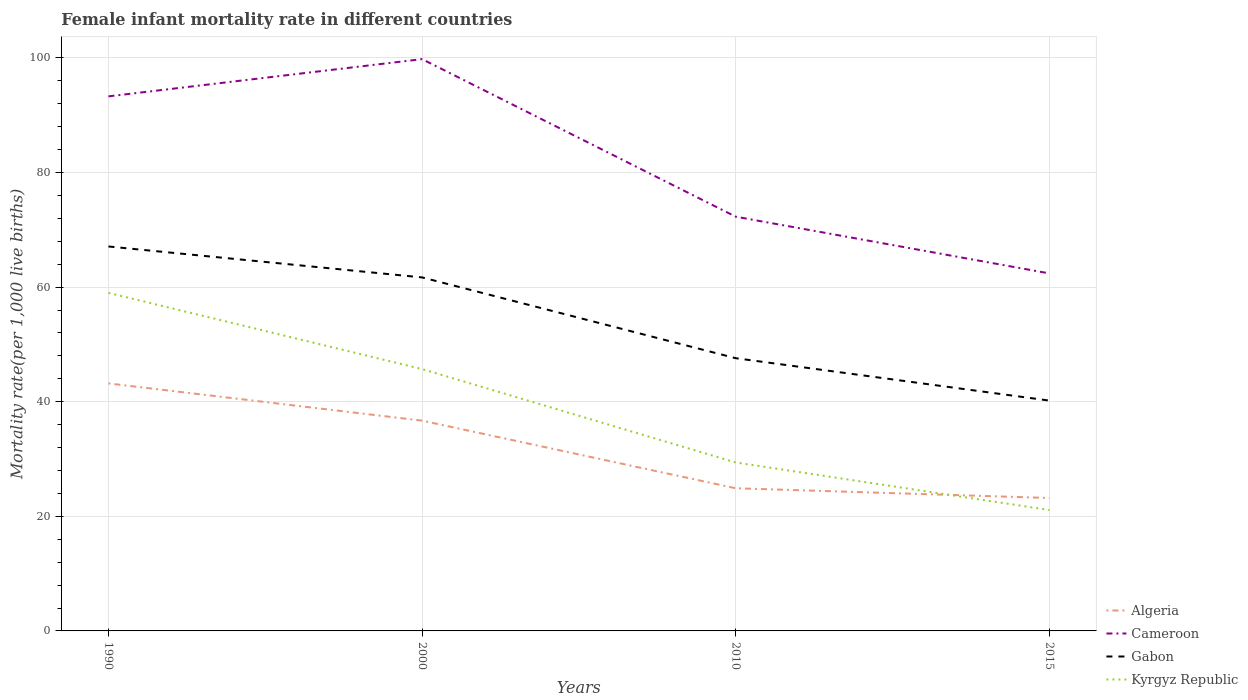How many different coloured lines are there?
Offer a terse response. 4. Across all years, what is the maximum female infant mortality rate in Gabon?
Your answer should be compact. 40.2. In which year was the female infant mortality rate in Cameroon maximum?
Your answer should be very brief. 2015. What is the total female infant mortality rate in Kyrgyz Republic in the graph?
Offer a terse response. 8.3. What is the difference between the highest and the second highest female infant mortality rate in Algeria?
Offer a terse response. 20. What is the difference between the highest and the lowest female infant mortality rate in Kyrgyz Republic?
Ensure brevity in your answer.  2. Is the female infant mortality rate in Kyrgyz Republic strictly greater than the female infant mortality rate in Cameroon over the years?
Give a very brief answer. Yes. How many years are there in the graph?
Give a very brief answer. 4. Are the values on the major ticks of Y-axis written in scientific E-notation?
Offer a terse response. No. Does the graph contain any zero values?
Make the answer very short. No. Does the graph contain grids?
Your answer should be very brief. Yes. How many legend labels are there?
Your answer should be compact. 4. How are the legend labels stacked?
Offer a terse response. Vertical. What is the title of the graph?
Give a very brief answer. Female infant mortality rate in different countries. Does "Azerbaijan" appear as one of the legend labels in the graph?
Your answer should be very brief. No. What is the label or title of the X-axis?
Provide a succinct answer. Years. What is the label or title of the Y-axis?
Your answer should be very brief. Mortality rate(per 1,0 live births). What is the Mortality rate(per 1,000 live births) of Algeria in 1990?
Your answer should be very brief. 43.2. What is the Mortality rate(per 1,000 live births) in Cameroon in 1990?
Offer a terse response. 93.3. What is the Mortality rate(per 1,000 live births) of Gabon in 1990?
Your answer should be very brief. 67.1. What is the Mortality rate(per 1,000 live births) of Kyrgyz Republic in 1990?
Give a very brief answer. 59. What is the Mortality rate(per 1,000 live births) of Algeria in 2000?
Offer a terse response. 36.7. What is the Mortality rate(per 1,000 live births) in Cameroon in 2000?
Keep it short and to the point. 99.8. What is the Mortality rate(per 1,000 live births) of Gabon in 2000?
Keep it short and to the point. 61.7. What is the Mortality rate(per 1,000 live births) of Kyrgyz Republic in 2000?
Provide a short and direct response. 45.7. What is the Mortality rate(per 1,000 live births) of Algeria in 2010?
Provide a succinct answer. 24.9. What is the Mortality rate(per 1,000 live births) in Cameroon in 2010?
Keep it short and to the point. 72.3. What is the Mortality rate(per 1,000 live births) in Gabon in 2010?
Offer a very short reply. 47.6. What is the Mortality rate(per 1,000 live births) of Kyrgyz Republic in 2010?
Your response must be concise. 29.4. What is the Mortality rate(per 1,000 live births) in Algeria in 2015?
Give a very brief answer. 23.2. What is the Mortality rate(per 1,000 live births) of Cameroon in 2015?
Give a very brief answer. 62.4. What is the Mortality rate(per 1,000 live births) in Gabon in 2015?
Keep it short and to the point. 40.2. What is the Mortality rate(per 1,000 live births) of Kyrgyz Republic in 2015?
Offer a terse response. 21.1. Across all years, what is the maximum Mortality rate(per 1,000 live births) of Algeria?
Keep it short and to the point. 43.2. Across all years, what is the maximum Mortality rate(per 1,000 live births) in Cameroon?
Your answer should be compact. 99.8. Across all years, what is the maximum Mortality rate(per 1,000 live births) in Gabon?
Your answer should be compact. 67.1. Across all years, what is the minimum Mortality rate(per 1,000 live births) of Algeria?
Your answer should be very brief. 23.2. Across all years, what is the minimum Mortality rate(per 1,000 live births) of Cameroon?
Your answer should be very brief. 62.4. Across all years, what is the minimum Mortality rate(per 1,000 live births) of Gabon?
Offer a very short reply. 40.2. Across all years, what is the minimum Mortality rate(per 1,000 live births) of Kyrgyz Republic?
Make the answer very short. 21.1. What is the total Mortality rate(per 1,000 live births) in Algeria in the graph?
Your answer should be compact. 128. What is the total Mortality rate(per 1,000 live births) of Cameroon in the graph?
Keep it short and to the point. 327.8. What is the total Mortality rate(per 1,000 live births) in Gabon in the graph?
Your response must be concise. 216.6. What is the total Mortality rate(per 1,000 live births) in Kyrgyz Republic in the graph?
Your answer should be very brief. 155.2. What is the difference between the Mortality rate(per 1,000 live births) in Cameroon in 1990 and that in 2000?
Give a very brief answer. -6.5. What is the difference between the Mortality rate(per 1,000 live births) of Kyrgyz Republic in 1990 and that in 2000?
Your response must be concise. 13.3. What is the difference between the Mortality rate(per 1,000 live births) of Cameroon in 1990 and that in 2010?
Your answer should be very brief. 21. What is the difference between the Mortality rate(per 1,000 live births) of Kyrgyz Republic in 1990 and that in 2010?
Provide a short and direct response. 29.6. What is the difference between the Mortality rate(per 1,000 live births) in Algeria in 1990 and that in 2015?
Make the answer very short. 20. What is the difference between the Mortality rate(per 1,000 live births) of Cameroon in 1990 and that in 2015?
Your answer should be compact. 30.9. What is the difference between the Mortality rate(per 1,000 live births) of Gabon in 1990 and that in 2015?
Offer a terse response. 26.9. What is the difference between the Mortality rate(per 1,000 live births) of Kyrgyz Republic in 1990 and that in 2015?
Provide a succinct answer. 37.9. What is the difference between the Mortality rate(per 1,000 live births) of Algeria in 2000 and that in 2010?
Your answer should be very brief. 11.8. What is the difference between the Mortality rate(per 1,000 live births) of Cameroon in 2000 and that in 2010?
Give a very brief answer. 27.5. What is the difference between the Mortality rate(per 1,000 live births) of Kyrgyz Republic in 2000 and that in 2010?
Give a very brief answer. 16.3. What is the difference between the Mortality rate(per 1,000 live births) of Cameroon in 2000 and that in 2015?
Offer a very short reply. 37.4. What is the difference between the Mortality rate(per 1,000 live births) in Kyrgyz Republic in 2000 and that in 2015?
Keep it short and to the point. 24.6. What is the difference between the Mortality rate(per 1,000 live births) in Algeria in 2010 and that in 2015?
Make the answer very short. 1.7. What is the difference between the Mortality rate(per 1,000 live births) in Gabon in 2010 and that in 2015?
Your response must be concise. 7.4. What is the difference between the Mortality rate(per 1,000 live births) of Kyrgyz Republic in 2010 and that in 2015?
Ensure brevity in your answer.  8.3. What is the difference between the Mortality rate(per 1,000 live births) in Algeria in 1990 and the Mortality rate(per 1,000 live births) in Cameroon in 2000?
Make the answer very short. -56.6. What is the difference between the Mortality rate(per 1,000 live births) of Algeria in 1990 and the Mortality rate(per 1,000 live births) of Gabon in 2000?
Provide a succinct answer. -18.5. What is the difference between the Mortality rate(per 1,000 live births) in Algeria in 1990 and the Mortality rate(per 1,000 live births) in Kyrgyz Republic in 2000?
Give a very brief answer. -2.5. What is the difference between the Mortality rate(per 1,000 live births) in Cameroon in 1990 and the Mortality rate(per 1,000 live births) in Gabon in 2000?
Offer a very short reply. 31.6. What is the difference between the Mortality rate(per 1,000 live births) in Cameroon in 1990 and the Mortality rate(per 1,000 live births) in Kyrgyz Republic in 2000?
Give a very brief answer. 47.6. What is the difference between the Mortality rate(per 1,000 live births) of Gabon in 1990 and the Mortality rate(per 1,000 live births) of Kyrgyz Republic in 2000?
Your answer should be compact. 21.4. What is the difference between the Mortality rate(per 1,000 live births) in Algeria in 1990 and the Mortality rate(per 1,000 live births) in Cameroon in 2010?
Provide a succinct answer. -29.1. What is the difference between the Mortality rate(per 1,000 live births) in Cameroon in 1990 and the Mortality rate(per 1,000 live births) in Gabon in 2010?
Provide a short and direct response. 45.7. What is the difference between the Mortality rate(per 1,000 live births) of Cameroon in 1990 and the Mortality rate(per 1,000 live births) of Kyrgyz Republic in 2010?
Your answer should be very brief. 63.9. What is the difference between the Mortality rate(per 1,000 live births) in Gabon in 1990 and the Mortality rate(per 1,000 live births) in Kyrgyz Republic in 2010?
Offer a terse response. 37.7. What is the difference between the Mortality rate(per 1,000 live births) of Algeria in 1990 and the Mortality rate(per 1,000 live births) of Cameroon in 2015?
Give a very brief answer. -19.2. What is the difference between the Mortality rate(per 1,000 live births) in Algeria in 1990 and the Mortality rate(per 1,000 live births) in Gabon in 2015?
Ensure brevity in your answer.  3. What is the difference between the Mortality rate(per 1,000 live births) of Algeria in 1990 and the Mortality rate(per 1,000 live births) of Kyrgyz Republic in 2015?
Keep it short and to the point. 22.1. What is the difference between the Mortality rate(per 1,000 live births) of Cameroon in 1990 and the Mortality rate(per 1,000 live births) of Gabon in 2015?
Your response must be concise. 53.1. What is the difference between the Mortality rate(per 1,000 live births) of Cameroon in 1990 and the Mortality rate(per 1,000 live births) of Kyrgyz Republic in 2015?
Make the answer very short. 72.2. What is the difference between the Mortality rate(per 1,000 live births) of Algeria in 2000 and the Mortality rate(per 1,000 live births) of Cameroon in 2010?
Give a very brief answer. -35.6. What is the difference between the Mortality rate(per 1,000 live births) in Algeria in 2000 and the Mortality rate(per 1,000 live births) in Kyrgyz Republic in 2010?
Offer a very short reply. 7.3. What is the difference between the Mortality rate(per 1,000 live births) of Cameroon in 2000 and the Mortality rate(per 1,000 live births) of Gabon in 2010?
Offer a terse response. 52.2. What is the difference between the Mortality rate(per 1,000 live births) of Cameroon in 2000 and the Mortality rate(per 1,000 live births) of Kyrgyz Republic in 2010?
Your response must be concise. 70.4. What is the difference between the Mortality rate(per 1,000 live births) in Gabon in 2000 and the Mortality rate(per 1,000 live births) in Kyrgyz Republic in 2010?
Make the answer very short. 32.3. What is the difference between the Mortality rate(per 1,000 live births) of Algeria in 2000 and the Mortality rate(per 1,000 live births) of Cameroon in 2015?
Make the answer very short. -25.7. What is the difference between the Mortality rate(per 1,000 live births) of Cameroon in 2000 and the Mortality rate(per 1,000 live births) of Gabon in 2015?
Make the answer very short. 59.6. What is the difference between the Mortality rate(per 1,000 live births) in Cameroon in 2000 and the Mortality rate(per 1,000 live births) in Kyrgyz Republic in 2015?
Offer a terse response. 78.7. What is the difference between the Mortality rate(per 1,000 live births) in Gabon in 2000 and the Mortality rate(per 1,000 live births) in Kyrgyz Republic in 2015?
Keep it short and to the point. 40.6. What is the difference between the Mortality rate(per 1,000 live births) of Algeria in 2010 and the Mortality rate(per 1,000 live births) of Cameroon in 2015?
Offer a very short reply. -37.5. What is the difference between the Mortality rate(per 1,000 live births) in Algeria in 2010 and the Mortality rate(per 1,000 live births) in Gabon in 2015?
Your answer should be very brief. -15.3. What is the difference between the Mortality rate(per 1,000 live births) in Algeria in 2010 and the Mortality rate(per 1,000 live births) in Kyrgyz Republic in 2015?
Offer a terse response. 3.8. What is the difference between the Mortality rate(per 1,000 live births) of Cameroon in 2010 and the Mortality rate(per 1,000 live births) of Gabon in 2015?
Offer a terse response. 32.1. What is the difference between the Mortality rate(per 1,000 live births) of Cameroon in 2010 and the Mortality rate(per 1,000 live births) of Kyrgyz Republic in 2015?
Your answer should be very brief. 51.2. What is the difference between the Mortality rate(per 1,000 live births) in Gabon in 2010 and the Mortality rate(per 1,000 live births) in Kyrgyz Republic in 2015?
Offer a terse response. 26.5. What is the average Mortality rate(per 1,000 live births) in Cameroon per year?
Your answer should be very brief. 81.95. What is the average Mortality rate(per 1,000 live births) in Gabon per year?
Provide a short and direct response. 54.15. What is the average Mortality rate(per 1,000 live births) in Kyrgyz Republic per year?
Provide a short and direct response. 38.8. In the year 1990, what is the difference between the Mortality rate(per 1,000 live births) of Algeria and Mortality rate(per 1,000 live births) of Cameroon?
Offer a terse response. -50.1. In the year 1990, what is the difference between the Mortality rate(per 1,000 live births) of Algeria and Mortality rate(per 1,000 live births) of Gabon?
Give a very brief answer. -23.9. In the year 1990, what is the difference between the Mortality rate(per 1,000 live births) of Algeria and Mortality rate(per 1,000 live births) of Kyrgyz Republic?
Provide a succinct answer. -15.8. In the year 1990, what is the difference between the Mortality rate(per 1,000 live births) in Cameroon and Mortality rate(per 1,000 live births) in Gabon?
Provide a succinct answer. 26.2. In the year 1990, what is the difference between the Mortality rate(per 1,000 live births) in Cameroon and Mortality rate(per 1,000 live births) in Kyrgyz Republic?
Offer a terse response. 34.3. In the year 1990, what is the difference between the Mortality rate(per 1,000 live births) of Gabon and Mortality rate(per 1,000 live births) of Kyrgyz Republic?
Ensure brevity in your answer.  8.1. In the year 2000, what is the difference between the Mortality rate(per 1,000 live births) of Algeria and Mortality rate(per 1,000 live births) of Cameroon?
Make the answer very short. -63.1. In the year 2000, what is the difference between the Mortality rate(per 1,000 live births) in Cameroon and Mortality rate(per 1,000 live births) in Gabon?
Your answer should be very brief. 38.1. In the year 2000, what is the difference between the Mortality rate(per 1,000 live births) in Cameroon and Mortality rate(per 1,000 live births) in Kyrgyz Republic?
Provide a succinct answer. 54.1. In the year 2000, what is the difference between the Mortality rate(per 1,000 live births) in Gabon and Mortality rate(per 1,000 live births) in Kyrgyz Republic?
Give a very brief answer. 16. In the year 2010, what is the difference between the Mortality rate(per 1,000 live births) of Algeria and Mortality rate(per 1,000 live births) of Cameroon?
Ensure brevity in your answer.  -47.4. In the year 2010, what is the difference between the Mortality rate(per 1,000 live births) of Algeria and Mortality rate(per 1,000 live births) of Gabon?
Ensure brevity in your answer.  -22.7. In the year 2010, what is the difference between the Mortality rate(per 1,000 live births) in Cameroon and Mortality rate(per 1,000 live births) in Gabon?
Offer a terse response. 24.7. In the year 2010, what is the difference between the Mortality rate(per 1,000 live births) of Cameroon and Mortality rate(per 1,000 live births) of Kyrgyz Republic?
Your answer should be compact. 42.9. In the year 2010, what is the difference between the Mortality rate(per 1,000 live births) in Gabon and Mortality rate(per 1,000 live births) in Kyrgyz Republic?
Ensure brevity in your answer.  18.2. In the year 2015, what is the difference between the Mortality rate(per 1,000 live births) of Algeria and Mortality rate(per 1,000 live births) of Cameroon?
Your response must be concise. -39.2. In the year 2015, what is the difference between the Mortality rate(per 1,000 live births) in Algeria and Mortality rate(per 1,000 live births) in Gabon?
Ensure brevity in your answer.  -17. In the year 2015, what is the difference between the Mortality rate(per 1,000 live births) in Algeria and Mortality rate(per 1,000 live births) in Kyrgyz Republic?
Provide a succinct answer. 2.1. In the year 2015, what is the difference between the Mortality rate(per 1,000 live births) in Cameroon and Mortality rate(per 1,000 live births) in Gabon?
Offer a terse response. 22.2. In the year 2015, what is the difference between the Mortality rate(per 1,000 live births) of Cameroon and Mortality rate(per 1,000 live births) of Kyrgyz Republic?
Your answer should be very brief. 41.3. In the year 2015, what is the difference between the Mortality rate(per 1,000 live births) of Gabon and Mortality rate(per 1,000 live births) of Kyrgyz Republic?
Your answer should be compact. 19.1. What is the ratio of the Mortality rate(per 1,000 live births) of Algeria in 1990 to that in 2000?
Offer a terse response. 1.18. What is the ratio of the Mortality rate(per 1,000 live births) of Cameroon in 1990 to that in 2000?
Give a very brief answer. 0.93. What is the ratio of the Mortality rate(per 1,000 live births) in Gabon in 1990 to that in 2000?
Provide a succinct answer. 1.09. What is the ratio of the Mortality rate(per 1,000 live births) of Kyrgyz Republic in 1990 to that in 2000?
Provide a succinct answer. 1.29. What is the ratio of the Mortality rate(per 1,000 live births) in Algeria in 1990 to that in 2010?
Your response must be concise. 1.73. What is the ratio of the Mortality rate(per 1,000 live births) in Cameroon in 1990 to that in 2010?
Make the answer very short. 1.29. What is the ratio of the Mortality rate(per 1,000 live births) of Gabon in 1990 to that in 2010?
Provide a short and direct response. 1.41. What is the ratio of the Mortality rate(per 1,000 live births) in Kyrgyz Republic in 1990 to that in 2010?
Provide a succinct answer. 2.01. What is the ratio of the Mortality rate(per 1,000 live births) of Algeria in 1990 to that in 2015?
Ensure brevity in your answer.  1.86. What is the ratio of the Mortality rate(per 1,000 live births) in Cameroon in 1990 to that in 2015?
Make the answer very short. 1.5. What is the ratio of the Mortality rate(per 1,000 live births) of Gabon in 1990 to that in 2015?
Provide a short and direct response. 1.67. What is the ratio of the Mortality rate(per 1,000 live births) of Kyrgyz Republic in 1990 to that in 2015?
Give a very brief answer. 2.8. What is the ratio of the Mortality rate(per 1,000 live births) of Algeria in 2000 to that in 2010?
Provide a succinct answer. 1.47. What is the ratio of the Mortality rate(per 1,000 live births) of Cameroon in 2000 to that in 2010?
Make the answer very short. 1.38. What is the ratio of the Mortality rate(per 1,000 live births) in Gabon in 2000 to that in 2010?
Keep it short and to the point. 1.3. What is the ratio of the Mortality rate(per 1,000 live births) of Kyrgyz Republic in 2000 to that in 2010?
Provide a short and direct response. 1.55. What is the ratio of the Mortality rate(per 1,000 live births) in Algeria in 2000 to that in 2015?
Provide a short and direct response. 1.58. What is the ratio of the Mortality rate(per 1,000 live births) in Cameroon in 2000 to that in 2015?
Your answer should be compact. 1.6. What is the ratio of the Mortality rate(per 1,000 live births) of Gabon in 2000 to that in 2015?
Give a very brief answer. 1.53. What is the ratio of the Mortality rate(per 1,000 live births) in Kyrgyz Republic in 2000 to that in 2015?
Your answer should be compact. 2.17. What is the ratio of the Mortality rate(per 1,000 live births) in Algeria in 2010 to that in 2015?
Give a very brief answer. 1.07. What is the ratio of the Mortality rate(per 1,000 live births) of Cameroon in 2010 to that in 2015?
Your answer should be very brief. 1.16. What is the ratio of the Mortality rate(per 1,000 live births) in Gabon in 2010 to that in 2015?
Offer a terse response. 1.18. What is the ratio of the Mortality rate(per 1,000 live births) of Kyrgyz Republic in 2010 to that in 2015?
Give a very brief answer. 1.39. What is the difference between the highest and the second highest Mortality rate(per 1,000 live births) in Cameroon?
Your answer should be compact. 6.5. What is the difference between the highest and the second highest Mortality rate(per 1,000 live births) in Kyrgyz Republic?
Your answer should be very brief. 13.3. What is the difference between the highest and the lowest Mortality rate(per 1,000 live births) of Algeria?
Provide a short and direct response. 20. What is the difference between the highest and the lowest Mortality rate(per 1,000 live births) in Cameroon?
Your answer should be very brief. 37.4. What is the difference between the highest and the lowest Mortality rate(per 1,000 live births) in Gabon?
Give a very brief answer. 26.9. What is the difference between the highest and the lowest Mortality rate(per 1,000 live births) of Kyrgyz Republic?
Your response must be concise. 37.9. 